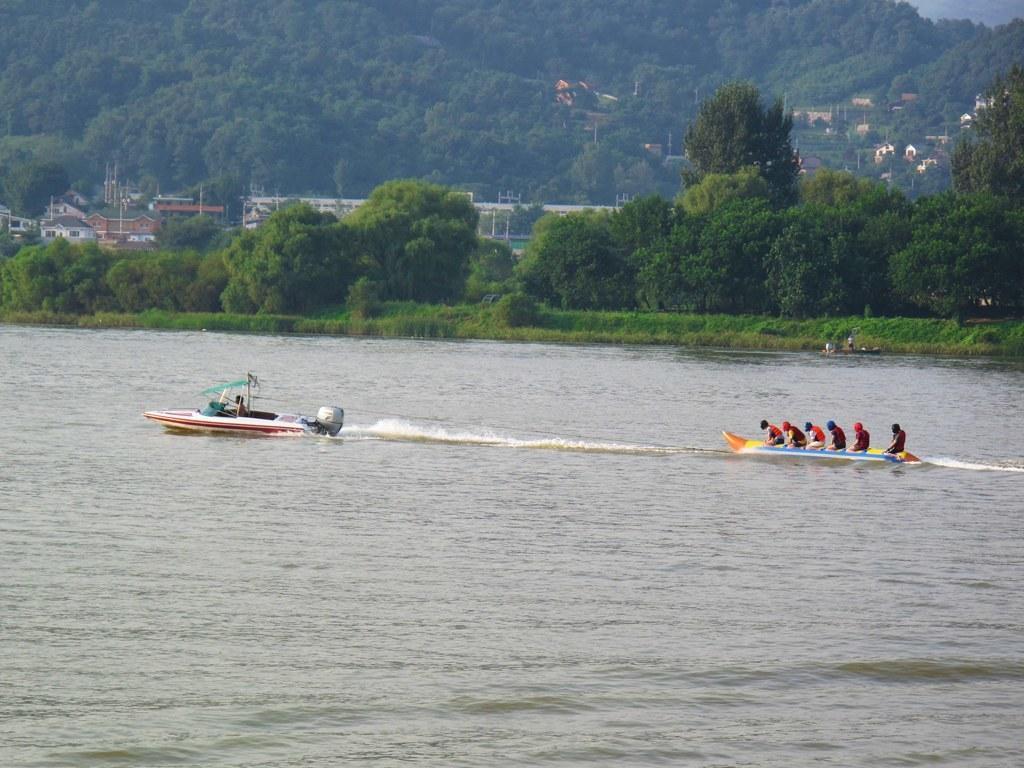Could you give a brief overview of what you see in this image? This picture is clicked outside the city. In the center we can see the group of persons in the sailboat and we can see the water body, plants, trees, houses and the grass. 